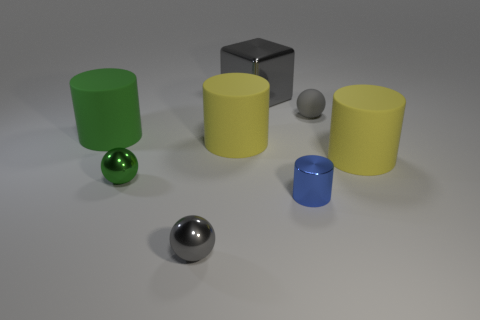There is a small object that is the same color as the small rubber ball; what shape is it?
Offer a terse response. Sphere. There is a metallic sphere that is the same color as the block; what size is it?
Your response must be concise. Small. What shape is the object that is both on the right side of the big gray shiny cube and on the left side of the small rubber object?
Make the answer very short. Cylinder. How many other objects are the same shape as the gray rubber thing?
Keep it short and to the point. 2. There is a gray metal object in front of the yellow rubber cylinder that is on the right side of the gray metallic object that is behind the large green thing; what is its shape?
Provide a succinct answer. Sphere. What number of objects are small blue metal cylinders or cylinders left of the gray rubber sphere?
Offer a very short reply. 3. There is a thing in front of the tiny blue thing; is its shape the same as the large object that is on the left side of the green metal ball?
Your answer should be compact. No. What number of things are either small red matte things or gray things?
Give a very brief answer. 3. Are there any other things that have the same material as the big gray thing?
Your answer should be very brief. Yes. Are any purple metal spheres visible?
Offer a terse response. No. 